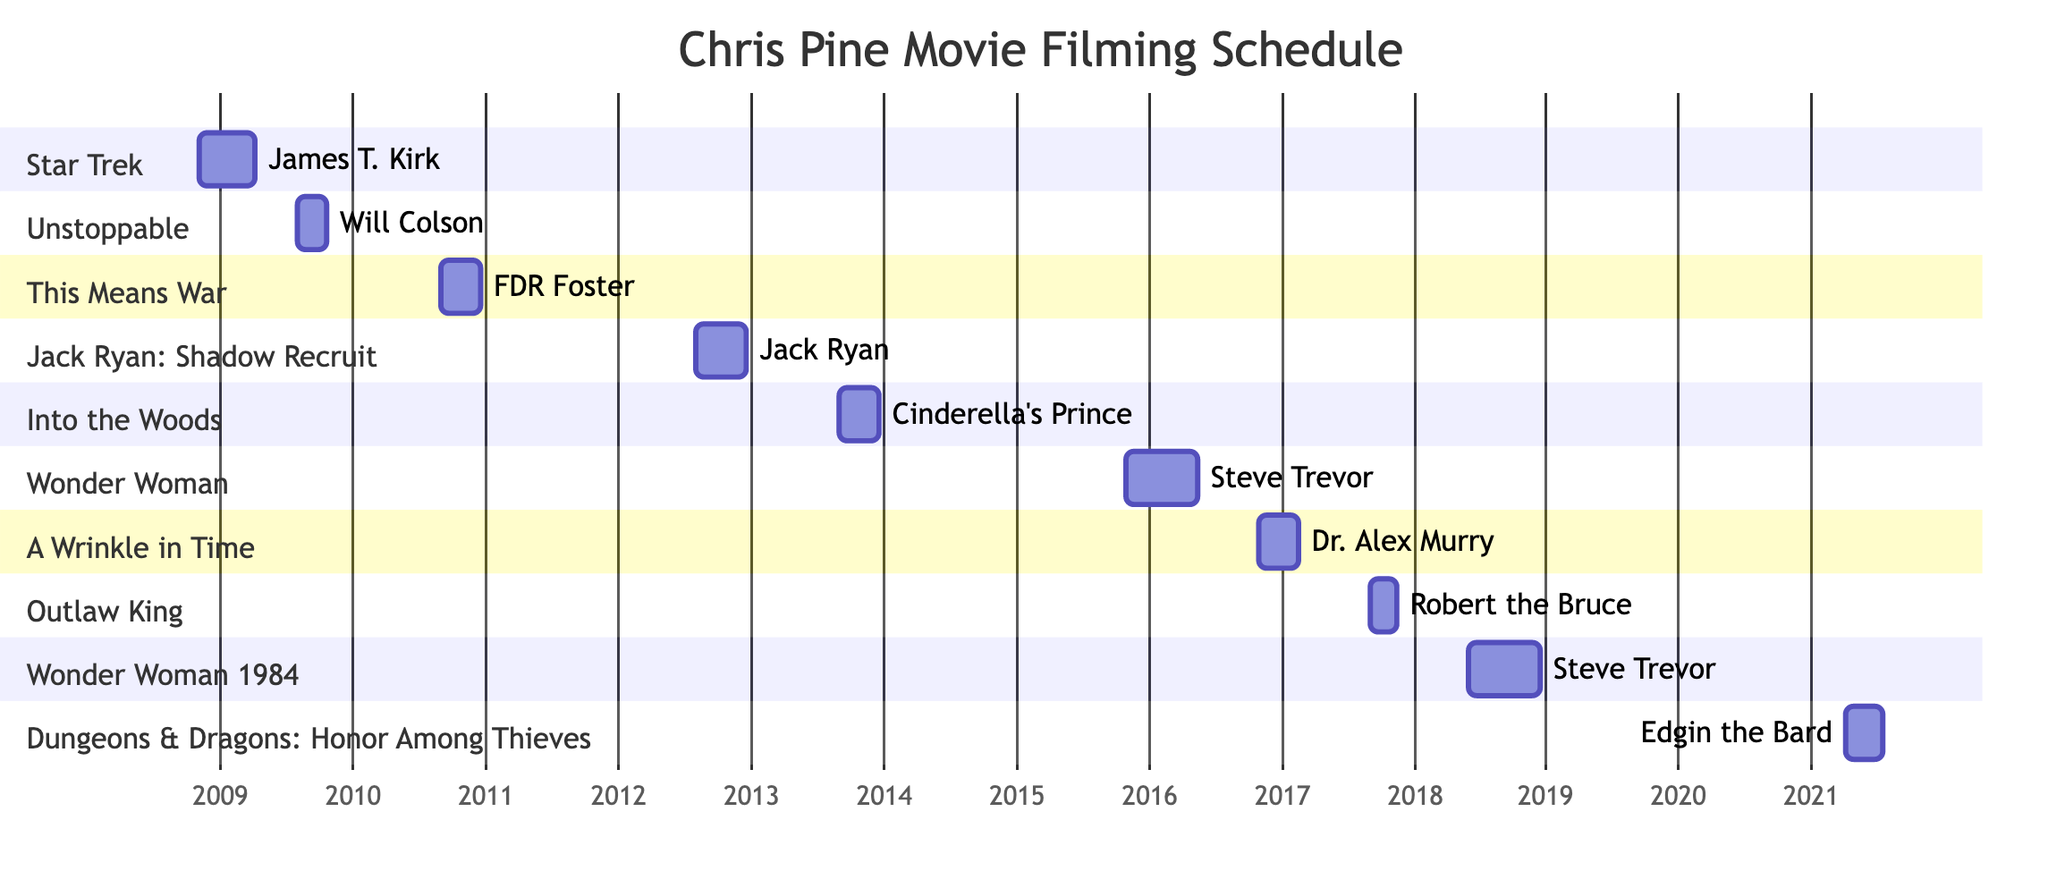What movie did Chris Pine film in 2009? By examining the Gantt chart, we can identify that there are two projects indicated in 2009: "Star Trek" and "Unstoppable." However, since the question specifies the year 2009, we highlight both movies that began filming during that year.
Answer: Star Trek, Unstoppable How many movies did Chris Pine work on in 2016? The Gantt chart shows two entries for 2016: "Wonder Woman" starting on November 1, 2015, and ending on May 15, 2016, and "A Wrinkle in Time" beginning on November 1, 2016, and concluding on February 15, 2017. Hence, only "Wonder Woman" is counted for movies that started filming in 2016.
Answer: 1 Which character did Chris Pine portray in "Wonder Woman"? In the diagram, it is noted that Chris Pine played the character "Steve Trevor" in the movie "Wonder Woman." This is directly visible in the corresponding section of the Gantt chart for that film.
Answer: Steve Trevor What is the longest filming duration for Chris Pine's movies shown in the chart? Analyzing the Gantt chart timeframe shows "Wonder Woman" lasting from November 1, 2015, to May 15, 2016, totaling about six months and fifteen days. Comparing against other projects indicates this is the longest duration.
Answer: 6 months 15 days Which movie’s filming dates overlap with "Outlaw King"? The Gantt chart indicates the filming period for "Outlaw King" from September 1 to November 15, 2017. "Wonder Woman 1984" begins on June 1, 2018, which does not overlap. The only other films that overlap in timing include "Jack Ryan: Shadow Recruit," which ends just before "Outlaw King” starts. Therefore, the answer is that "Jack Ryan: Shadow Recruit" overlaps with its production timing.
Answer: None What character was played by Chris Pine in "Dungeons & Dragons: Honor Among Thieves"? The chart specifies that Chris Pine portrayed "Edgin the Bard" in "Dungeons & Dragons: Honor Among Thieves," as indicated in the corresponding section of the Gantt chart.
Answer: Edgin the Bard What was the total number of movies filmed by Chris Pine from 2008 to 2021 according to the chart? The diagram lists movies from "Star Trek" in 2008 through to "Dungeons & Dragons: Honor Among Thieves" in 2021. Counting all distinct entries, there are a total of 10 movies shown in the Gantt chart.
Answer: 10 Which movie had the earliest filming start date? By examining the start dates of all the movies on the Gantt chart, it is evident that "Star Trek" started filming on November 1, 2008, making it the earliest among all listed films.
Answer: Star Trek 